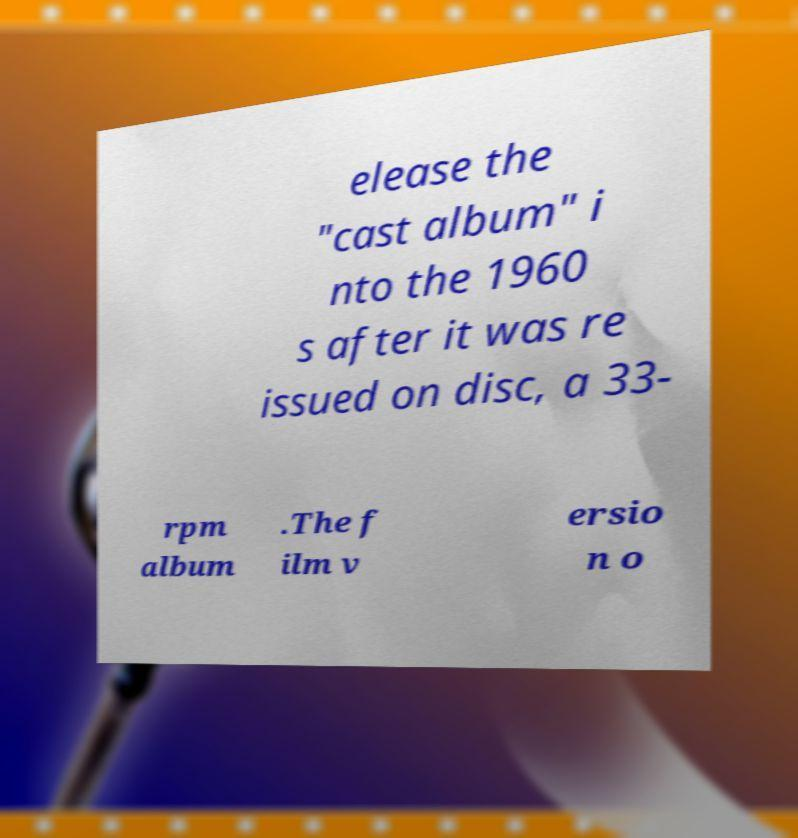Could you extract and type out the text from this image? elease the "cast album" i nto the 1960 s after it was re issued on disc, a 33- rpm album .The f ilm v ersio n o 